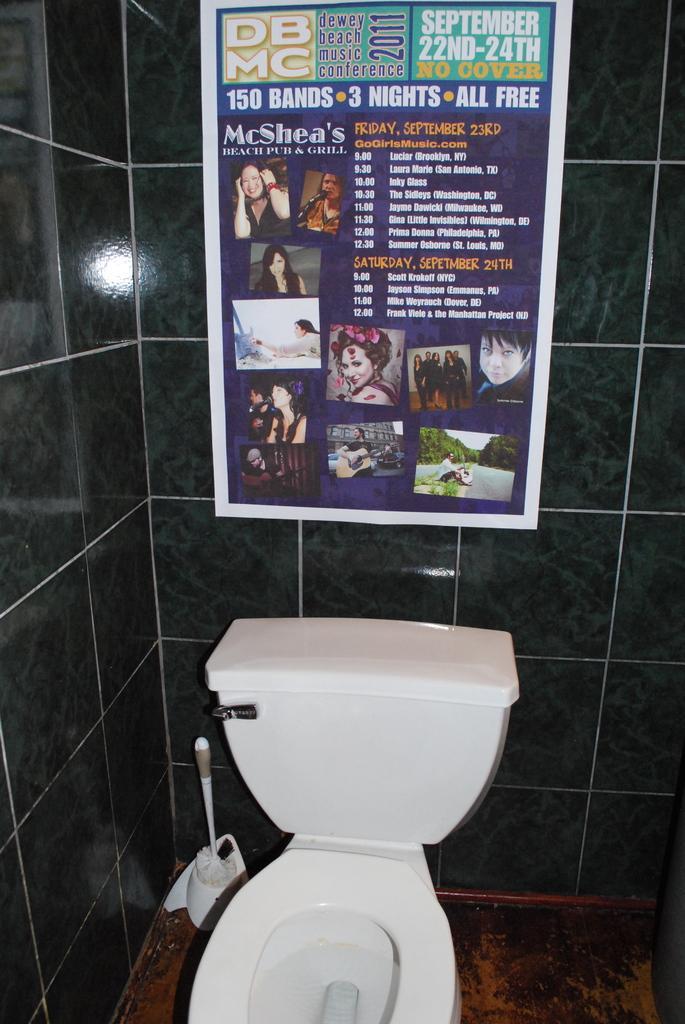Could you give a brief overview of what you see in this image? In the picture we can see commode, flush tank which are in white color, there is some poster attached to the wall and there is brush on floor. 